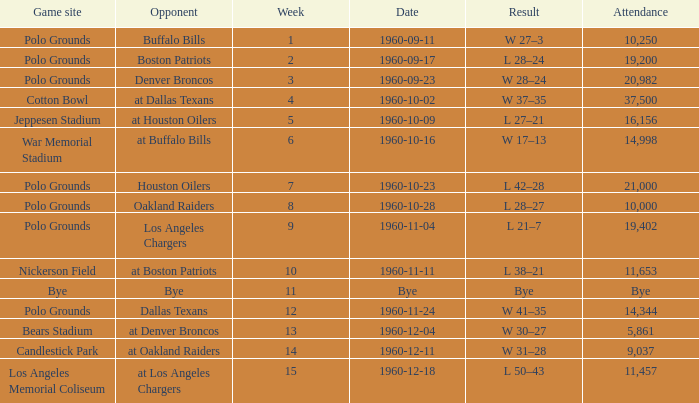What day did they play at candlestick park? 1960-12-11. 